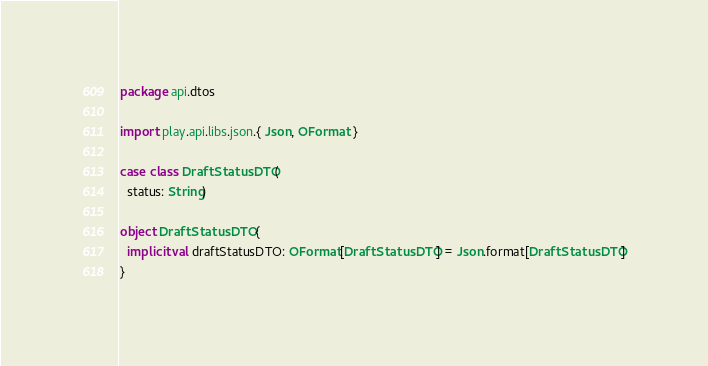<code> <loc_0><loc_0><loc_500><loc_500><_Scala_>package api.dtos

import play.api.libs.json.{ Json, OFormat }

case class DraftStatusDTO(
  status: String)

object DraftStatusDTO {
  implicit val draftStatusDTO: OFormat[DraftStatusDTO] = Json.format[DraftStatusDTO]
}</code> 